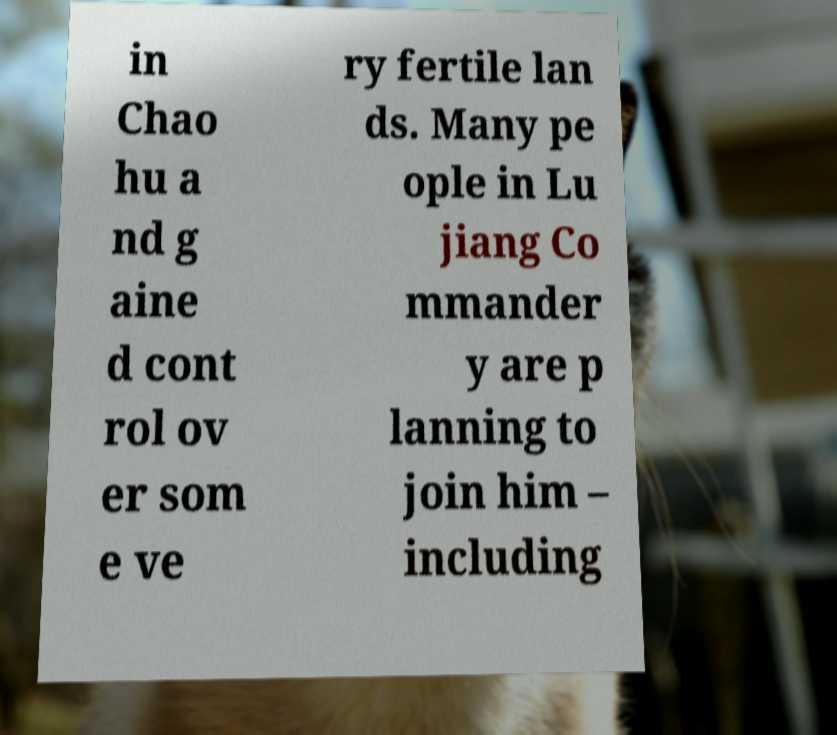There's text embedded in this image that I need extracted. Can you transcribe it verbatim? in Chao hu a nd g aine d cont rol ov er som e ve ry fertile lan ds. Many pe ople in Lu jiang Co mmander y are p lanning to join him – including 